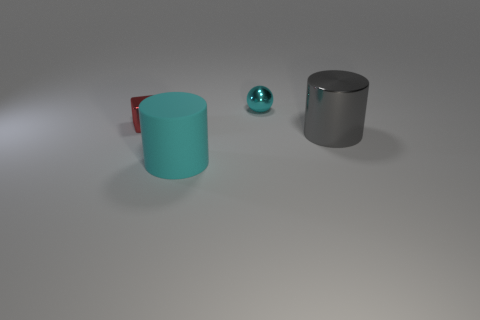Add 4 red cubes. How many objects exist? 8 Subtract all blocks. How many objects are left? 3 Subtract 0 yellow blocks. How many objects are left? 4 Subtract all tiny yellow balls. Subtract all small cyan metal spheres. How many objects are left? 3 Add 3 red metal blocks. How many red metal blocks are left? 4 Add 1 large blue rubber cylinders. How many large blue rubber cylinders exist? 1 